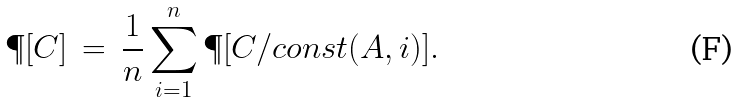<formula> <loc_0><loc_0><loc_500><loc_500>\P [ C ] \, = \, \frac { 1 } { n } \sum _ { i = 1 } ^ { n } \P [ C / c o n s t ( A , i ) ] .</formula> 